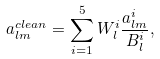<formula> <loc_0><loc_0><loc_500><loc_500>a _ { l m } ^ { c l e a n } = \sum _ { i = 1 } ^ { 5 } W _ { l } ^ { i } \frac { a _ { l m } ^ { i } } { B _ { l } ^ { i } } ,</formula> 